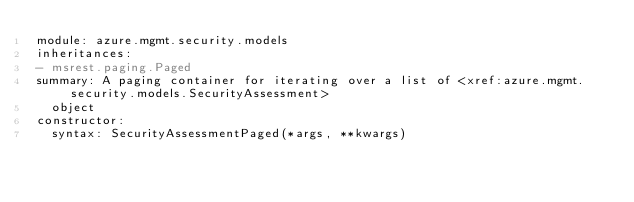<code> <loc_0><loc_0><loc_500><loc_500><_YAML_>module: azure.mgmt.security.models
inheritances:
- msrest.paging.Paged
summary: A paging container for iterating over a list of <xref:azure.mgmt.security.models.SecurityAssessment>
  object
constructor:
  syntax: SecurityAssessmentPaged(*args, **kwargs)
</code> 